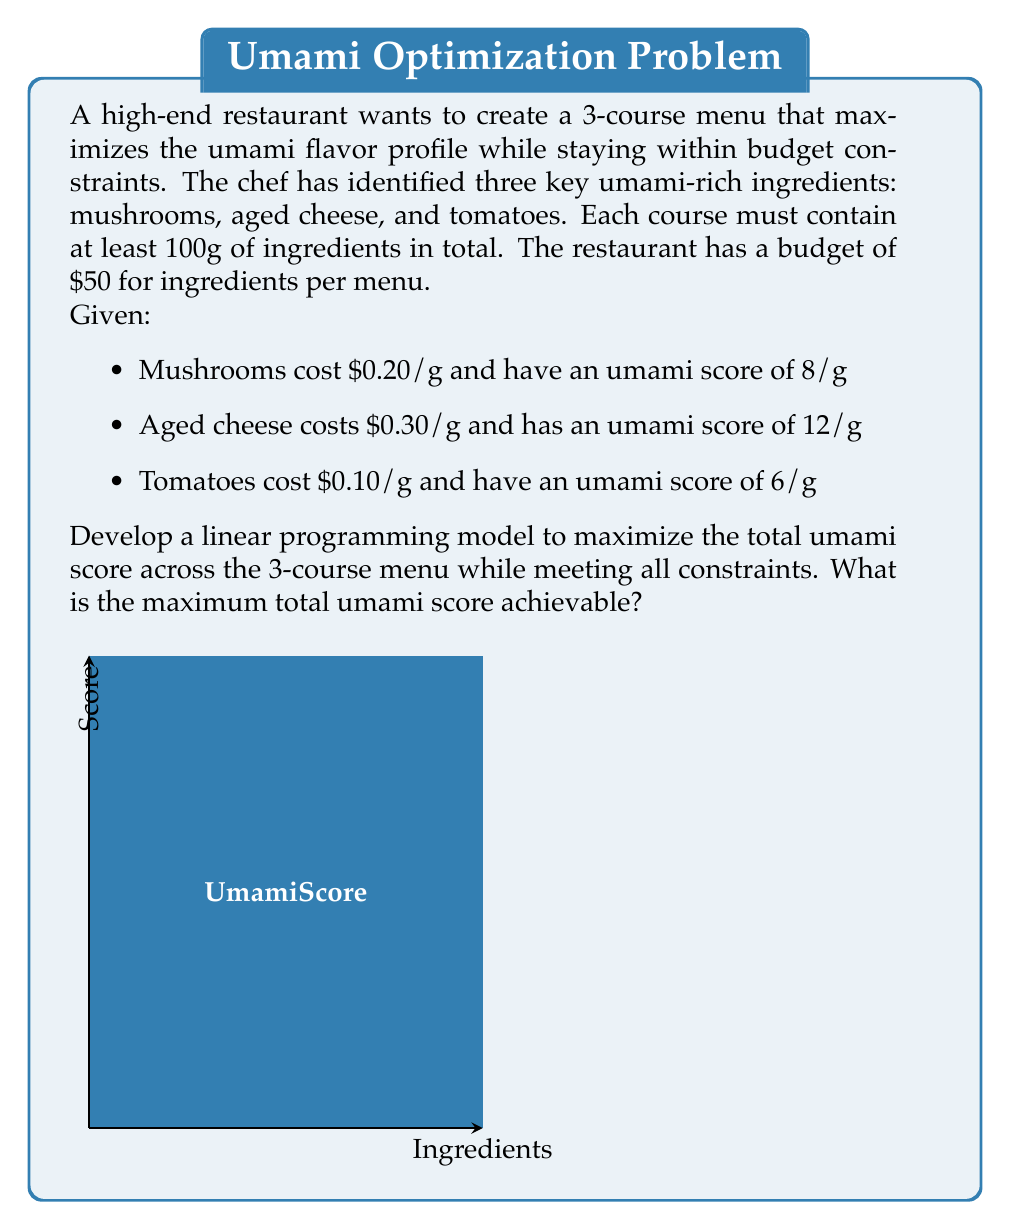Teach me how to tackle this problem. Let's approach this step-by-step:

1) Define variables:
   Let $x_i$, $y_i$, and $z_i$ be the grams of mushrooms, aged cheese, and tomatoes in course $i$ respectively, where $i = 1, 2, 3$.

2) Objective function:
   Maximize total umami score = $\sum_{i=1}^3 (8x_i + 12y_i + 6z_i)$

3) Constraints:
   a) Ingredient total for each course: $x_i + y_i + z_i \geq 100$ for $i = 1, 2, 3$
   b) Budget constraint: $0.2\sum_{i=1}^3 x_i + 0.3\sum_{i=1}^3 y_i + 0.1\sum_{i=1}^3 z_i \leq 50$
   c) Non-negativity: $x_i, y_i, z_i \geq 0$ for $i = 1, 2, 3$

4) The complete linear programming model:

   Maximize $\sum_{i=1}^3 (8x_i + 12y_i + 6z_i)$
   
   Subject to:
   $x_1 + y_1 + z_1 \geq 100$
   $x_2 + y_2 + z_2 \geq 100$
   $x_3 + y_3 + z_3 \geq 100$
   $0.2(x_1 + x_2 + x_3) + 0.3(y_1 + y_2 + y_3) + 0.1(z_1 + z_2 + z_3) \leq 50$
   $x_i, y_i, z_i \geq 0$ for $i = 1, 2, 3$

5) Solving this linear programming problem (using software like LINGO or Excel Solver) yields the optimal solution:
   $y_1 = y_2 = y_3 = 100$, all other variables = 0

6) The maximum umami score is therefore:
   $12 * 100 * 3 = 3600$

This solution suggests using only aged cheese in each course to maximize the umami score while meeting all constraints.
Answer: 3600 